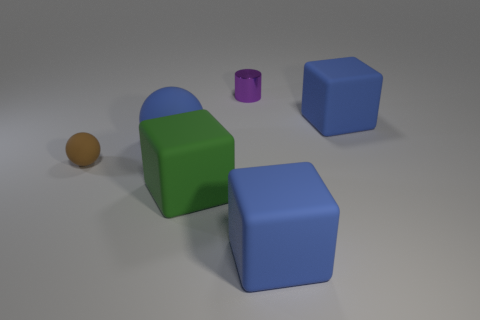Is there any other thing that is made of the same material as the purple object?
Your response must be concise. No. How many other objects are the same color as the big matte ball?
Your answer should be compact. 2. How many other things are there of the same material as the cylinder?
Provide a short and direct response. 0. Is the green block the same size as the blue ball?
Provide a succinct answer. Yes. What number of objects are rubber spheres that are on the right side of the tiny ball or large things?
Ensure brevity in your answer.  4. There is a large blue thing that is on the right side of the large blue thing in front of the large green matte cube; what is it made of?
Offer a very short reply. Rubber. Are there any tiny brown objects of the same shape as the small purple shiny thing?
Offer a terse response. No. There is a green rubber cube; is its size the same as the metal cylinder that is behind the big green block?
Offer a terse response. No. What number of objects are large blocks that are in front of the brown thing or big blue rubber cubes that are behind the tiny ball?
Your answer should be compact. 3. Are there more blue matte cubes that are in front of the tiny brown rubber sphere than yellow shiny cylinders?
Make the answer very short. Yes. 